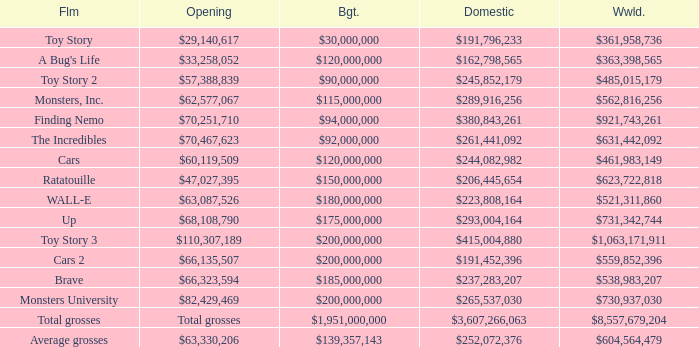WHAT IS THE BUDGET FOR THE INCREDIBLES? $92,000,000. 